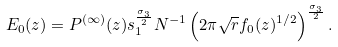<formula> <loc_0><loc_0><loc_500><loc_500>E _ { 0 } ( z ) = P ^ { ( \infty ) } ( z ) s _ { 1 } ^ { \frac { \sigma _ { 3 } } { 2 } } N ^ { - 1 } \left ( 2 \pi \sqrt { r } f _ { 0 } ( z ) ^ { 1 / 2 } \right ) ^ { \frac { \sigma _ { 3 } } { 2 } } .</formula> 